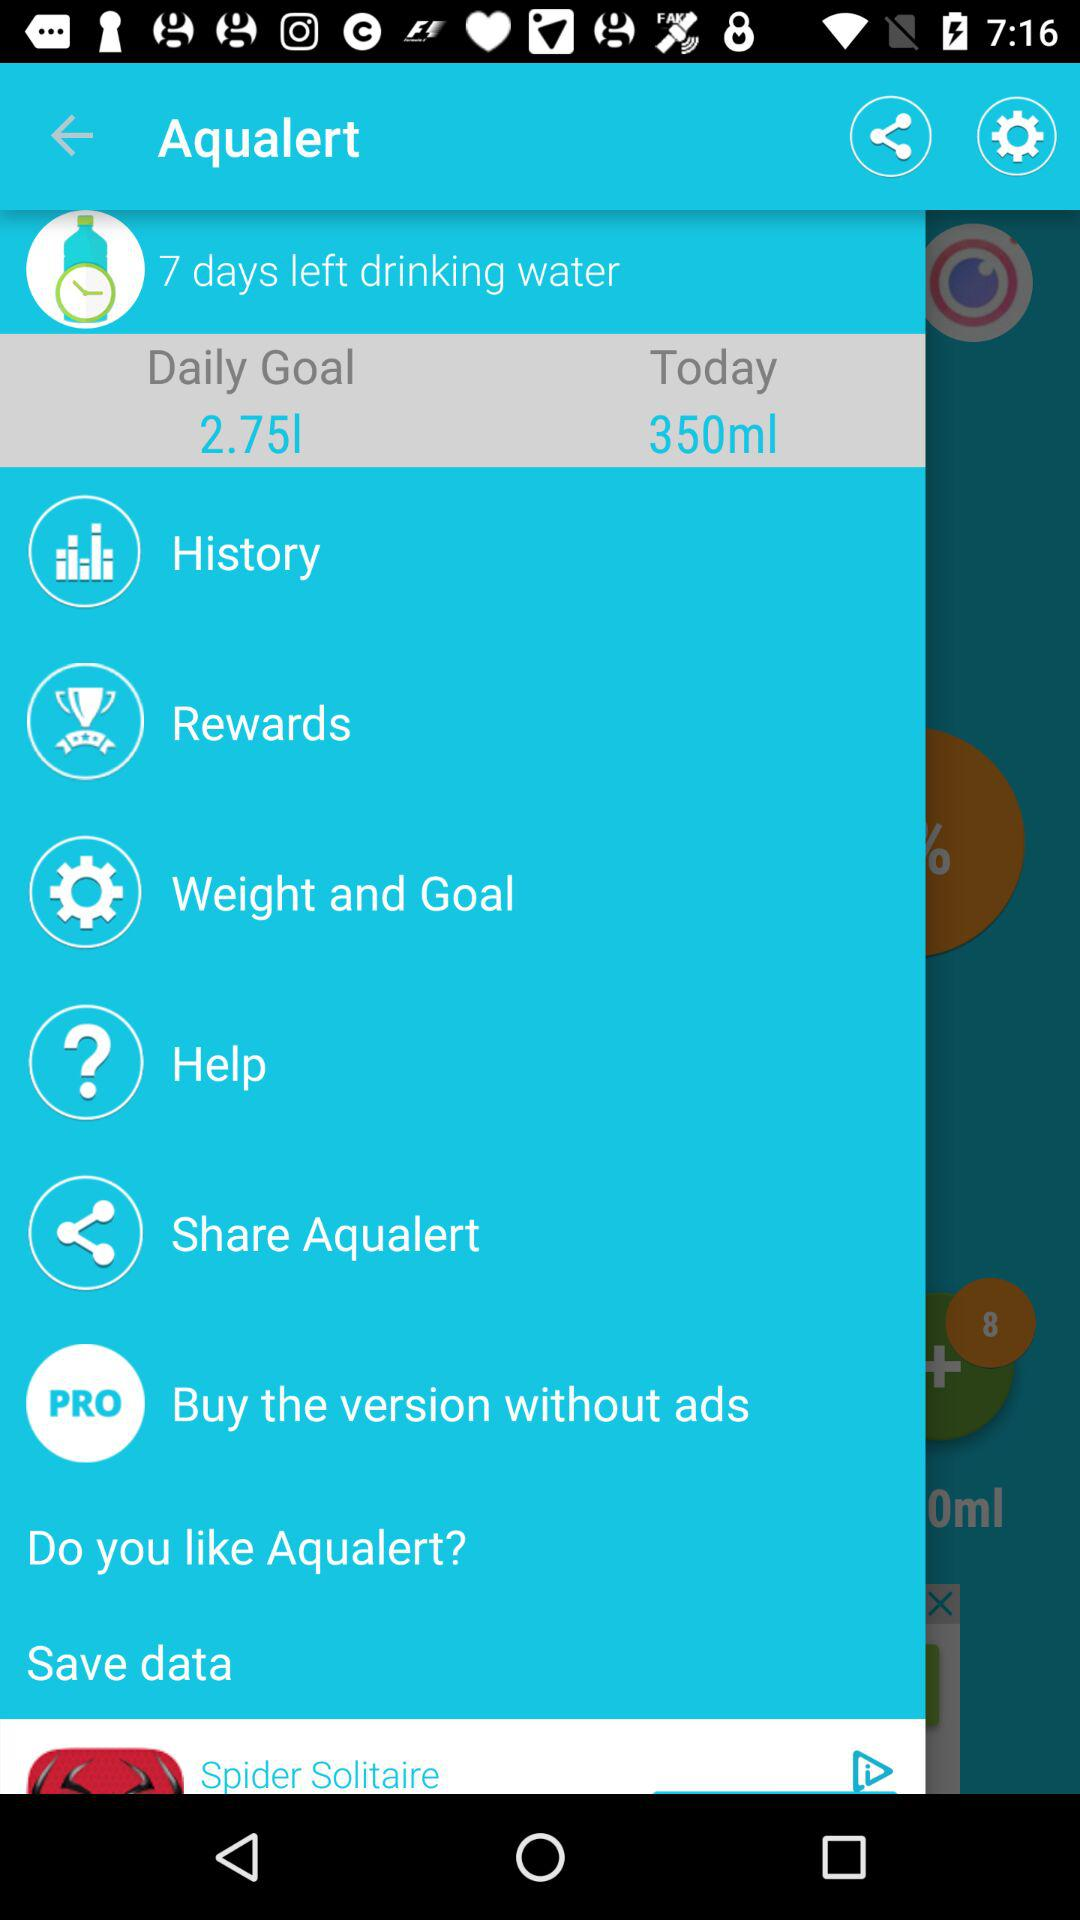How many days are left to complete the drinking water goal? The number of days left to complete the drinking water goal is 7. 